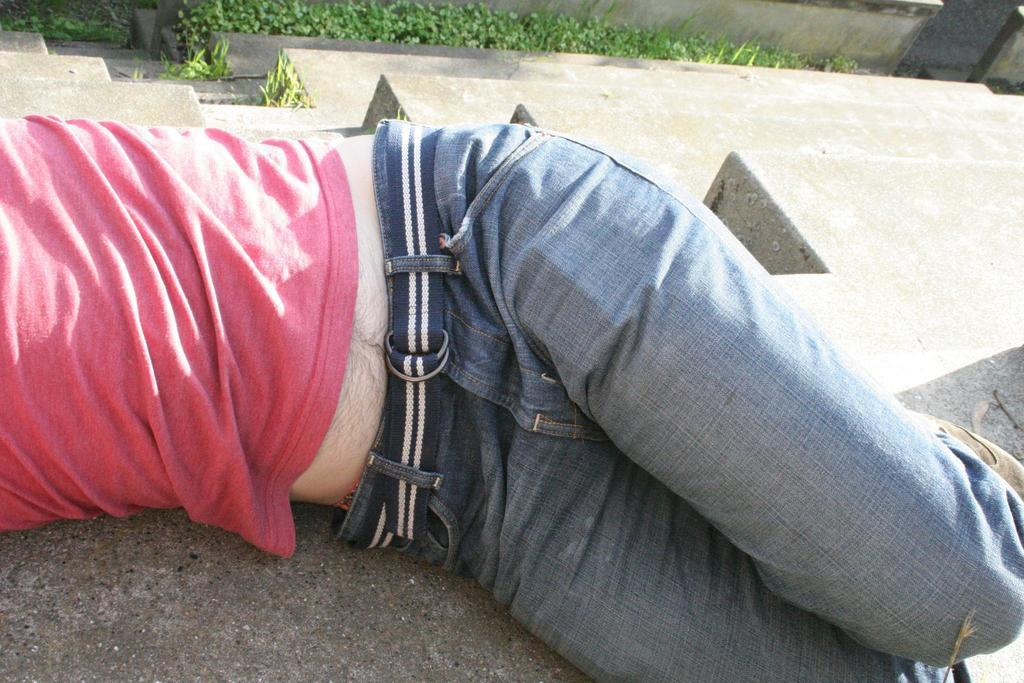What is the man in the foreground of the image doing? The man is lying down in the foreground of the image. What can be seen in the background of the image? There are steps, grass, plants near the compound wall, and a road visible in the background of the image. How many children are playing with a bubble in the image? There are no children or bubbles present in the image. What type of town can be seen in the background of the image? The image does not depict a town; it shows a man lying down, steps, grass, plants, and a road. 